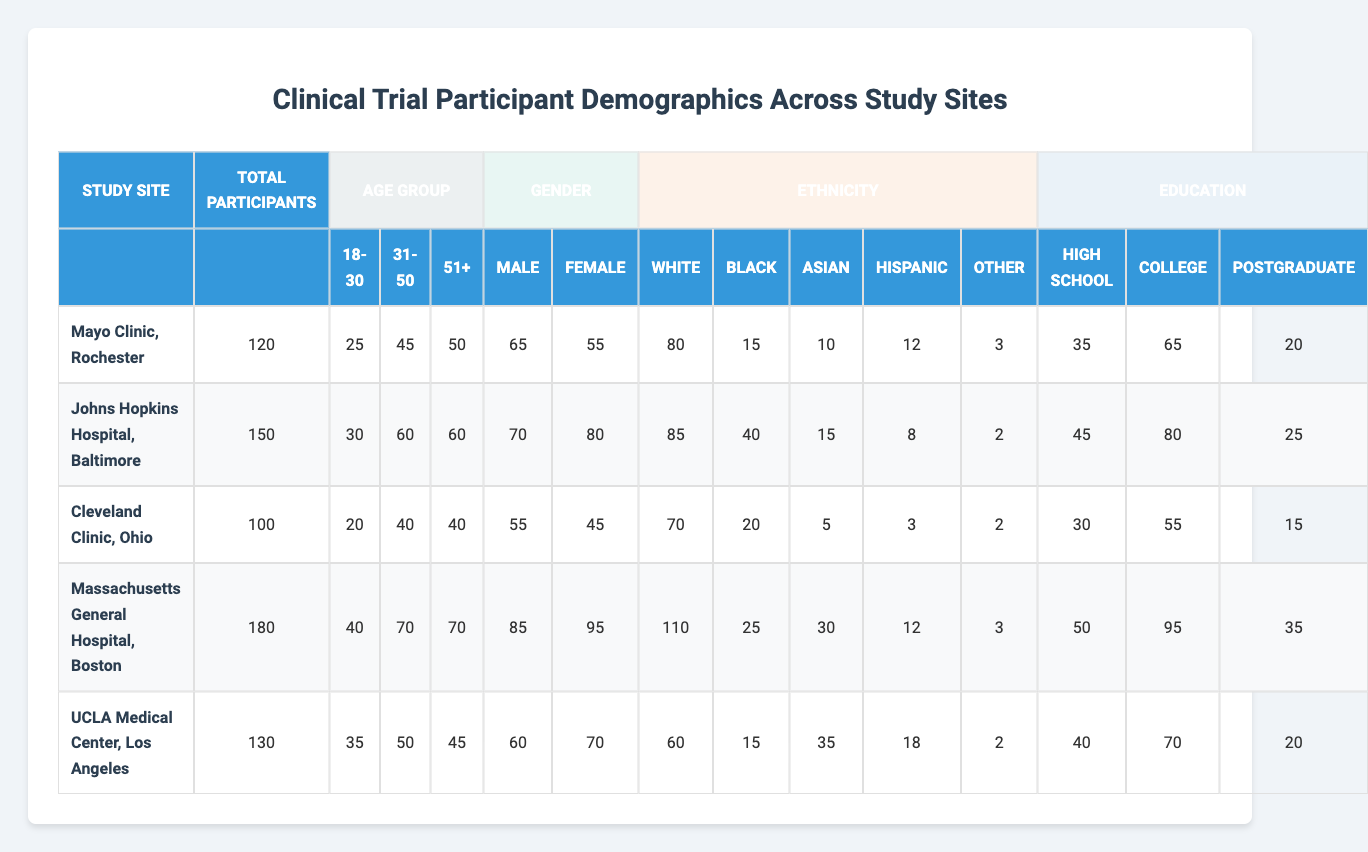What is the total number of participants at Massachusetts General Hospital? The total number of participants for Massachusetts General Hospital can be found in the table under the "Total Participants" column. It shows a value of 180.
Answer: 180 How many female participants are there at Johns Hopkins Hospital? The number of female participants at Johns Hopkins Hospital is listed under the "Female" column. The value is 80.
Answer: 80 Which study site has the highest number of male participants? To find the study site with the highest number of male participants, compare the values in the "Male" column for all sites. Massachusetts General Hospital has the highest value at 85.
Answer: Massachusetts General Hospital What is the percentage of participants aged 51 and older at the Cleveland Clinic? The number of participants aged 51 and older at Cleveland Clinic is 40. The total participants are 100. To find the percentage: (40/100) * 100 = 40%.
Answer: 40% How many participants at UCLA Medical Center identify as Hispanic? The table shows that the number of participants identifying as Hispanic at UCLA Medical Center is 18.
Answer: 18 What is the average number of participants aged 31 to 50 across all sites? The number of participants aged 31 to 50 are 45 (Mayo), 60 (Johns Hopkins), 40 (Cleveland), 70 (Massachusetts), and 50 (UCLA). To find the average, sum these values: 45 + 60 + 40 + 70 + 50 = 265, then divide by the number of sites (5): 265 / 5 = 53.
Answer: 53 Which study site has the lowest number of participants with postgraduate education? The table lists postgraduate education entries as 20 (Mayo), 25 (Johns Hopkins), 15 (Cleveland), 35 (Massachusetts), and 20 (UCLA). Cleveland has the lowest number at 15.
Answer: Cleveland Clinic, Ohio Is the majority of participants at any study site from the Asian ethnicity? To determine if any site has a majority of Asian participants, compare the "Asian" column values with the total participants at each site. The maximum value is 35 (UCLA), which is not a majority of 130 total participants; thus no site has a majority categorized as Asian.
Answer: No What is the difference in total participants between Mayo Clinic and the Massachusetts General Hospital? The total participants at Mayo Clinic is 120 and at Massachusetts General Hospital is 180. The difference is calculated as 180 - 120 = 60.
Answer: 60 At which site do the majority of participants have college-level education? The number of participants with college education is listed as 65 (Mayo), 80 (Johns Hopkins), 55 (Cleveland), 95 (Massachusetts), and 70 (UCLA). The majority is at Massachusetts General Hospital with 95 participants.
Answer: Massachusetts General Hospital 